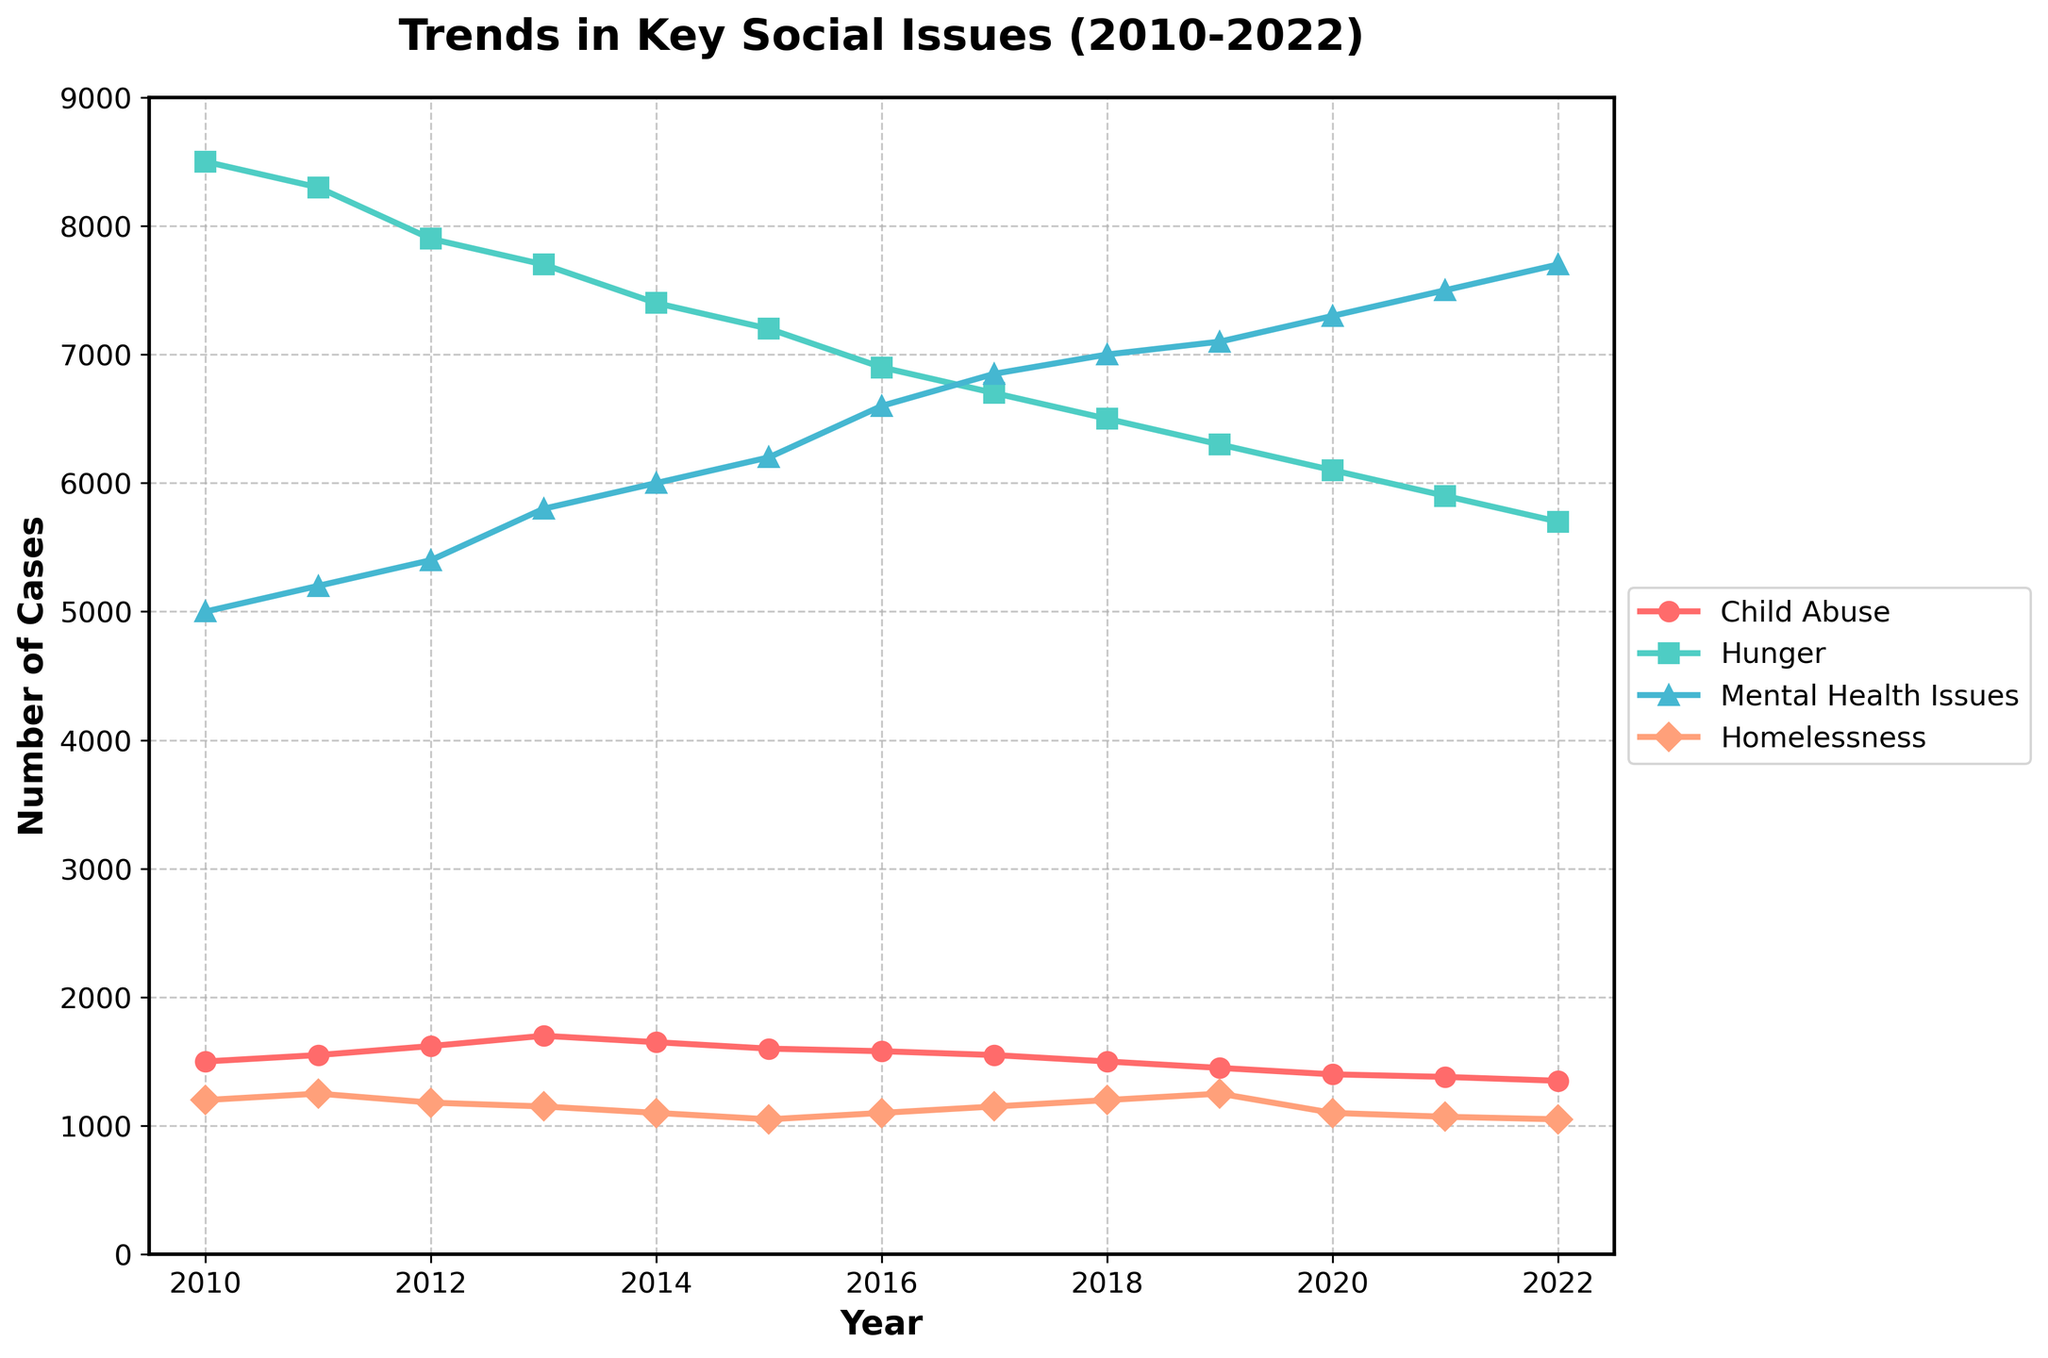what is the title of this plot? The title of the plot is displayed at the top in a large, bold font. It reads, "Trends in Key Social Issues (2010-2022)".
Answer: Trends in Key Social Issues (2010-2022) What does the x-axis represent? The x-axis is labeled 'Year', indicating it represents the years from 2010 to 2022.
Answer: Year Which social issue had the highest number of cases at the beginning of the period? At the beginning of the period, which is 2010, the number of cases for each social issue can be observed. Hunger had the highest number of cases with 8500 cases.
Answer: Hunger What is the trend shown by the "Mental Health Issues" line over time? From 2010 to 2022, the line representing "Mental Health Issues" shows a general upward trend, indicating an increase in cases over time.
Answer: Upward trend By how much did the number of "Child Abuse" cases decrease from 2010 to 2022? In 2010, there were 1500 "Child Abuse" cases, and in 2022, there were 1350 cases. The decrease is calculated as 1500 - 1350.
Answer: 150 During what year did "Homelessness" have the lowest number of cases? By observing the "Homelessness" line in the plot, the lowest point is at the year 2012, where the number of cases is 1180.
Answer: 2012 What is the difference in the number of "Hunger" cases between the highest and lowest points in the period shown? The highest number of "Hunger" cases is in 2010 with 8500 cases. The lowest is in 2022 with 5700 cases. The difference is 8500 - 5700.
Answer: 2800 Which social issue showed the most consistent decrease over the entire period? By observing all four lines from 2010 to 2022, "Hunger" shows a consistent decrease with no significant upward spikes.
Answer: Hunger In which year did "Mental Health Issues" surpass "Hunger" cases for the first time? By comparing the lines for "Mental Health Issues" and "Hunger", "Mental Health Issues" surpasses "Hunger" for the first time in 2016.
Answer: 2016 Which social issue had the smallest variation in total number of cases from 2010 to 2022? By observing the range of values for all social issues, "Homelessness" has the smallest range between its highest (1250 cases) and lowest (1050 cases) values.
Answer: Homelessness 